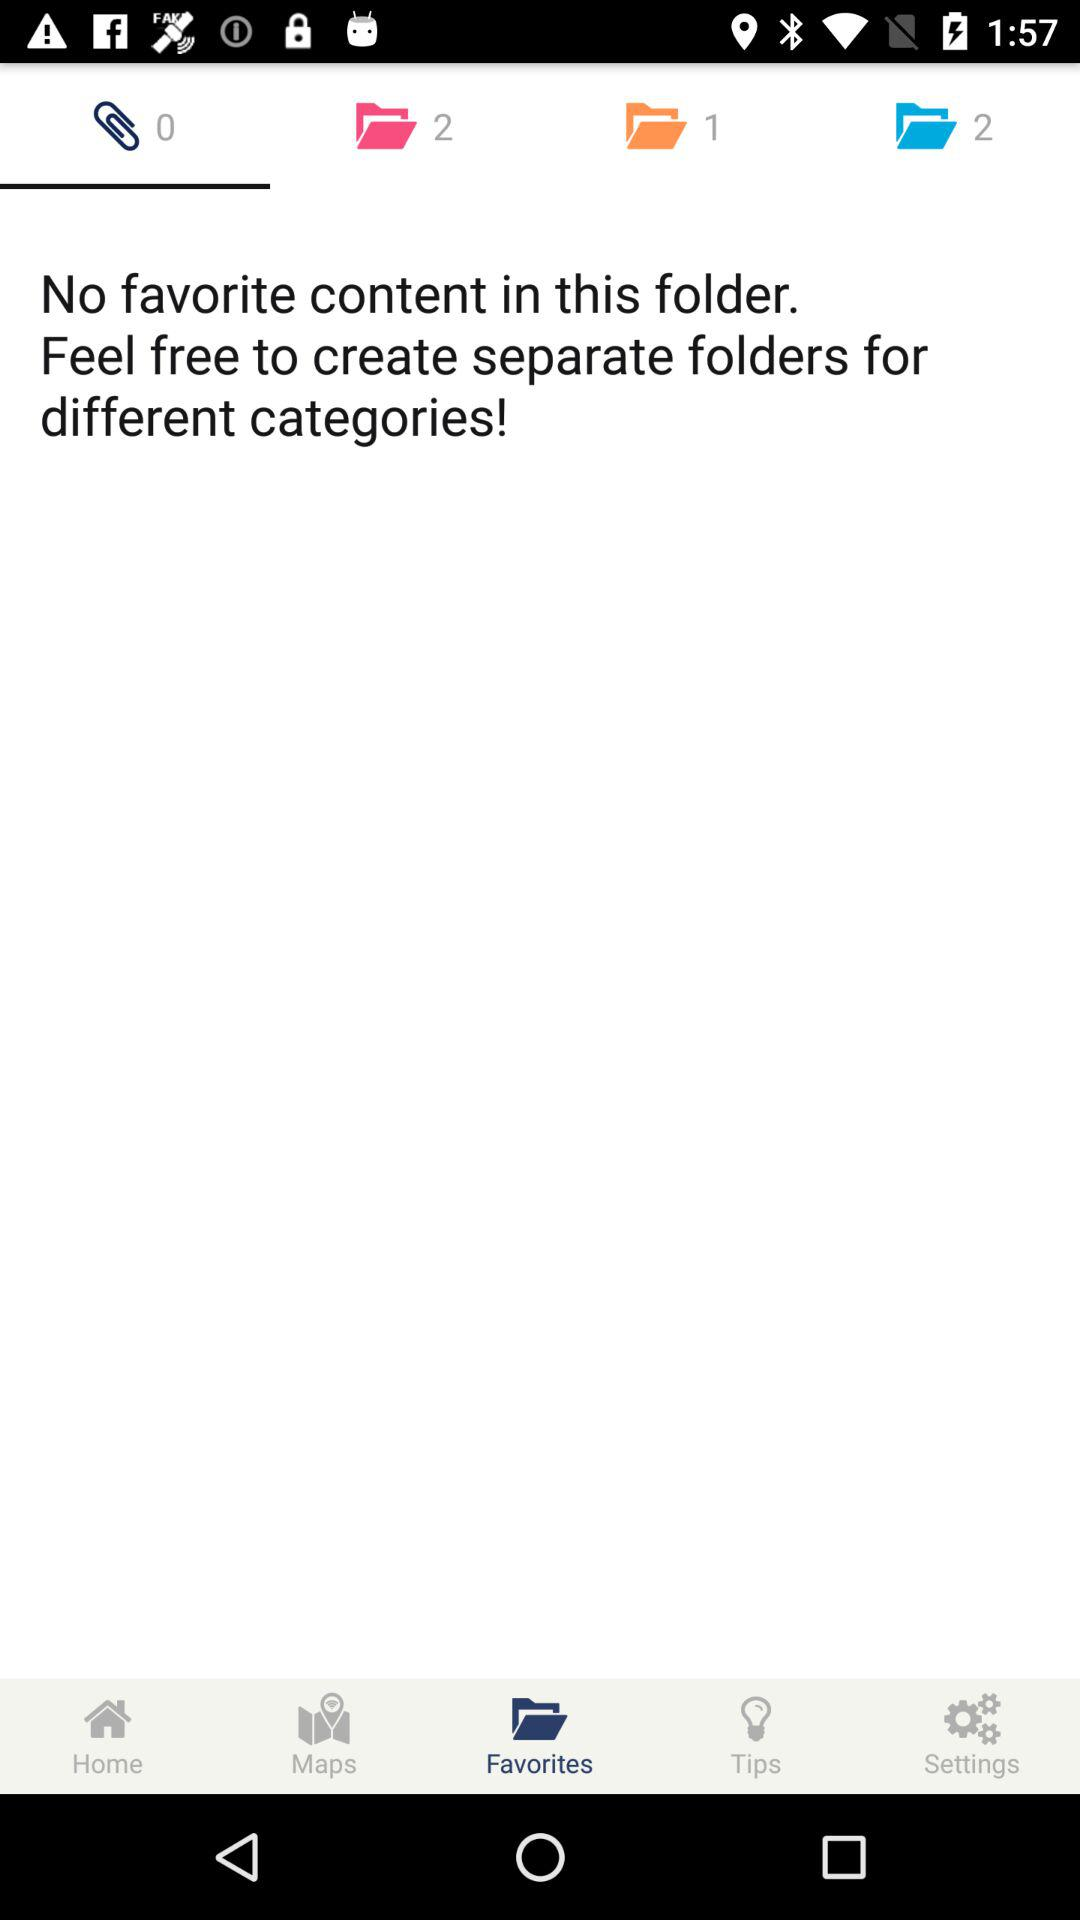Which tab am I using? You are using the "Attachment" and "Favorites" tabs. 